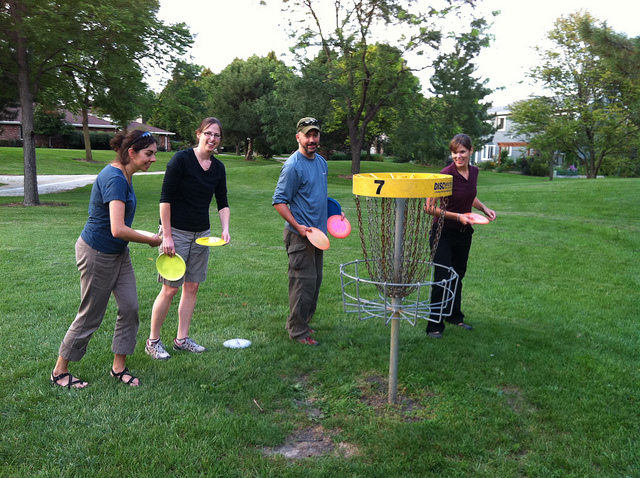<image>What sport is being played? I don't know what sport is being played. It can be Frisbee, Ultimate Frisbee, or Disc Golf. What sport is being played? It is not clear what sport is being played. It can be frisbee, ultimate frisbee, or disc golf. 